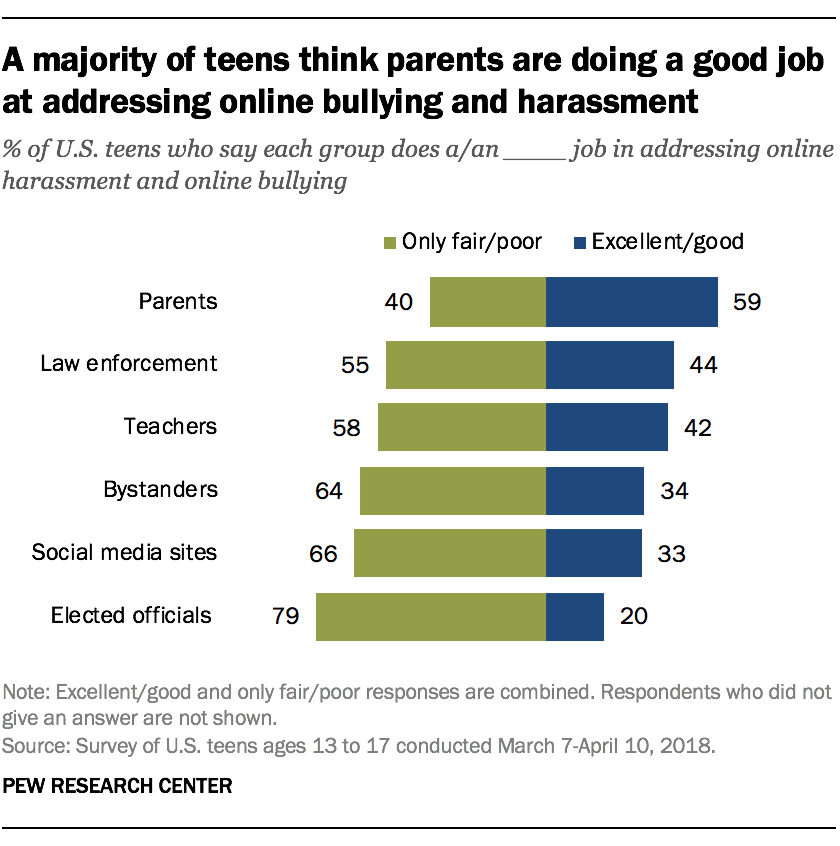Specify some key components in this picture. According to the survey, 40% of parents have an unfavorable opinion of our kindergarten. The median of green bars is 23 and the median of blue bars is 23. 